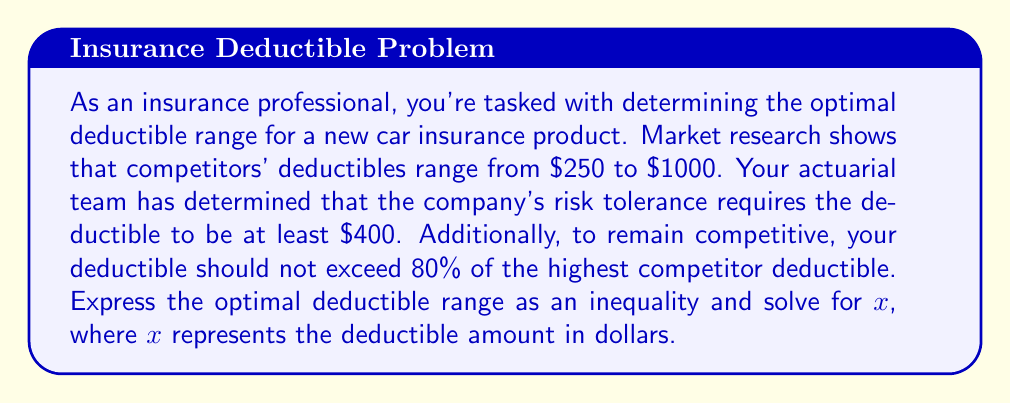Can you solve this math problem? Let's approach this step-by-step:

1) First, we need to identify the constraints:
   - The deductible must be at least $400
   - The deductible should not exceed 80% of the highest competitor deductible

2) We can express the lower bound as:
   $x \geq 400$

3) For the upper bound, we need to calculate 80% of the highest competitor deductible:
   Highest competitor deductible = $1000
   80% of $1000 = $1000 * 0.8 = $800

4) Now we can express the upper bound as:
   $x \leq 800$

5) Combining these inequalities, we get:
   $400 \leq x \leq 800$

6) This can also be written as a compound inequality:
   $400 \leq x \And x \leq 800$

This inequality represents the optimal deductible range for the new insurance product based on the given market constraints.
Answer: The optimal deductible range is:
$$400 \leq x \leq 800$$
where $x$ represents the deductible amount in dollars. 